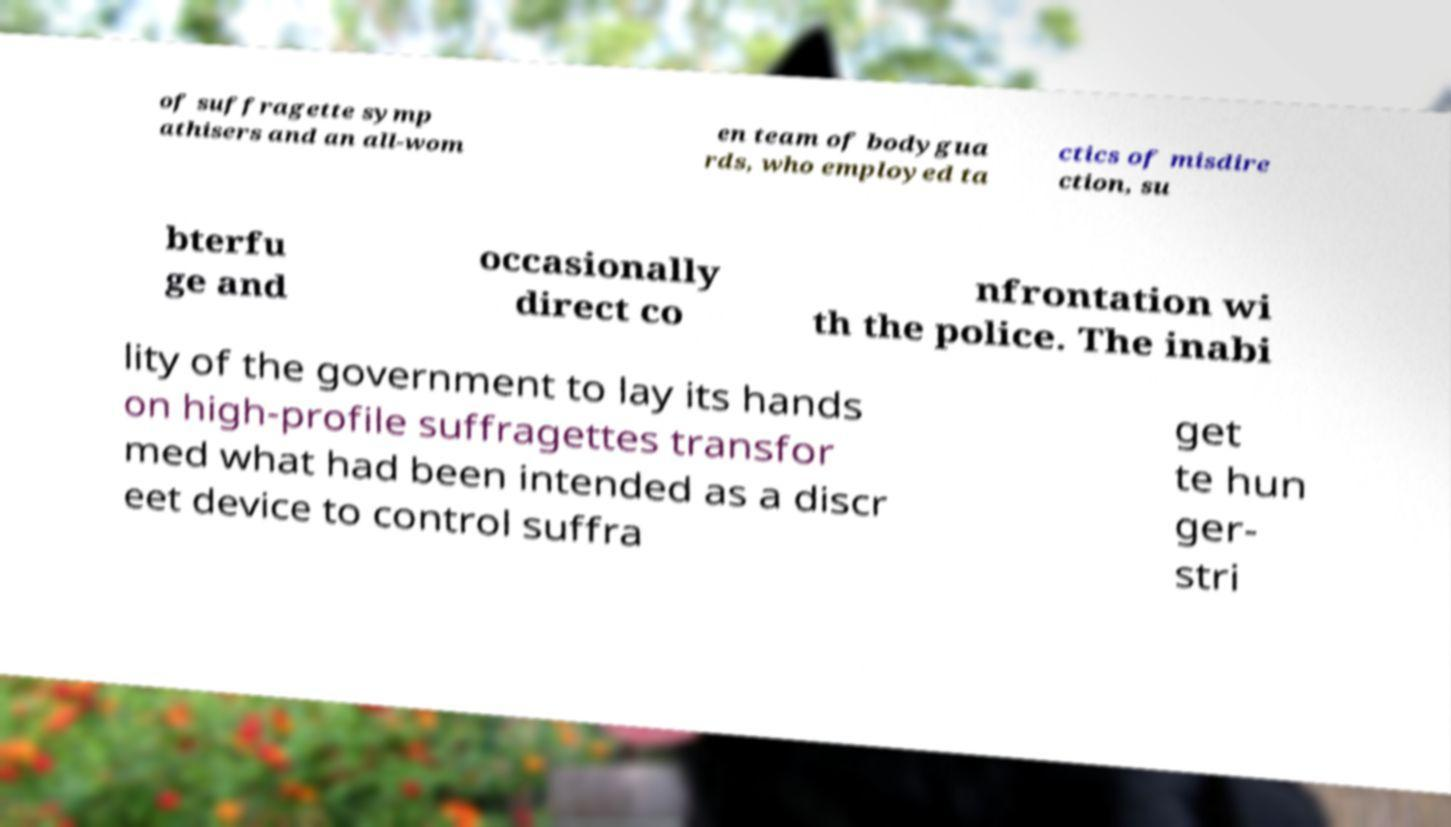Could you extract and type out the text from this image? of suffragette symp athisers and an all-wom en team of bodygua rds, who employed ta ctics of misdire ction, su bterfu ge and occasionally direct co nfrontation wi th the police. The inabi lity of the government to lay its hands on high-profile suffragettes transfor med what had been intended as a discr eet device to control suffra get te hun ger- stri 